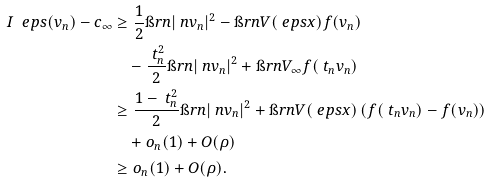Convert formula to latex. <formula><loc_0><loc_0><loc_500><loc_500>I _ { \ } e p s ( v _ { n } ) - c _ { \infty } & \geq \frac { 1 } { 2 } \i r n | \ n v _ { n } | ^ { 2 } - \i r n V ( \ e p s x ) f ( v _ { n } ) \\ & \quad - \frac { \ t _ { n } ^ { 2 } } 2 \i r n | \ n v _ { n } | ^ { 2 } + \i r n V _ { \infty } f ( \ t _ { n } v _ { n } ) \\ & \geq \frac { 1 - \ t _ { n } ^ { 2 } } { 2 } \i r n | \ n v _ { n } | ^ { 2 } + \i r n V ( \ e p s x ) \left ( f ( \ t _ { n } v _ { n } ) - f ( v _ { n } ) \right ) \\ & \quad + o _ { n } ( 1 ) + O ( \rho ) \\ & \geq o _ { n } ( 1 ) + O ( \rho ) .</formula> 